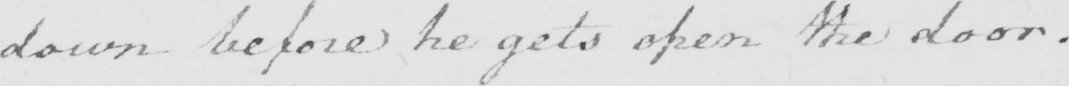Can you tell me what this handwritten text says? down before he gets open the door . 